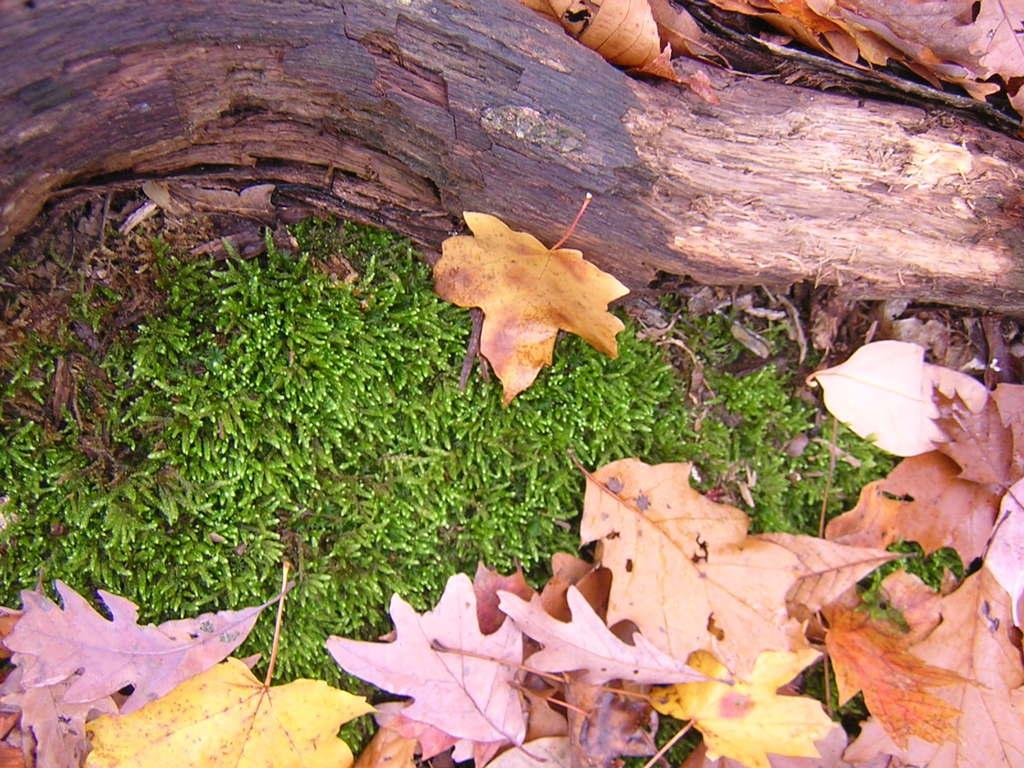Where was the image taken? The image is taken outdoors. What type of surface is visible in the image? There is a ground with grass in the image. What can be found on the ground in the image? There are dry leaves on the ground in the image. What is visible at the top of the image? There is a bark visible at the top of the image. What type of steel structure can be seen in the image? There is no steel structure present in the image. How many cakes are visible on the grass in the image? There are no cakes visible in the image; it features a ground with grass and dry leaves. 